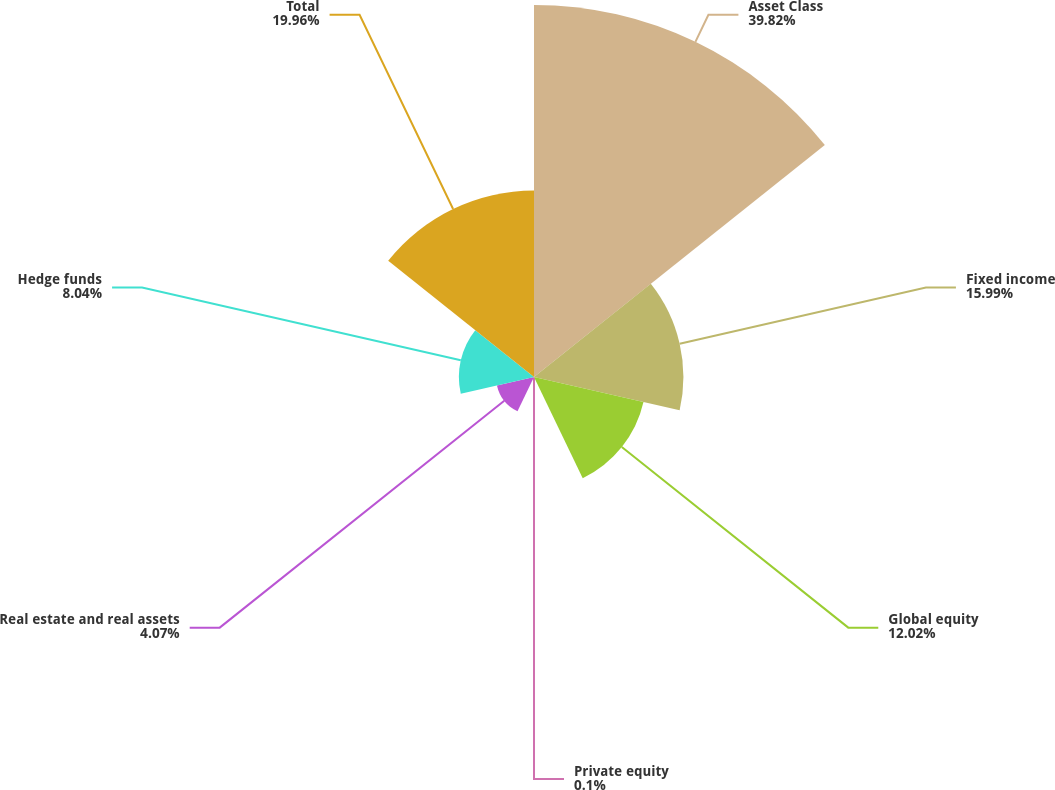<chart> <loc_0><loc_0><loc_500><loc_500><pie_chart><fcel>Asset Class<fcel>Fixed income<fcel>Global equity<fcel>Private equity<fcel>Real estate and real assets<fcel>Hedge funds<fcel>Total<nl><fcel>39.82%<fcel>15.99%<fcel>12.02%<fcel>0.1%<fcel>4.07%<fcel>8.04%<fcel>19.96%<nl></chart> 